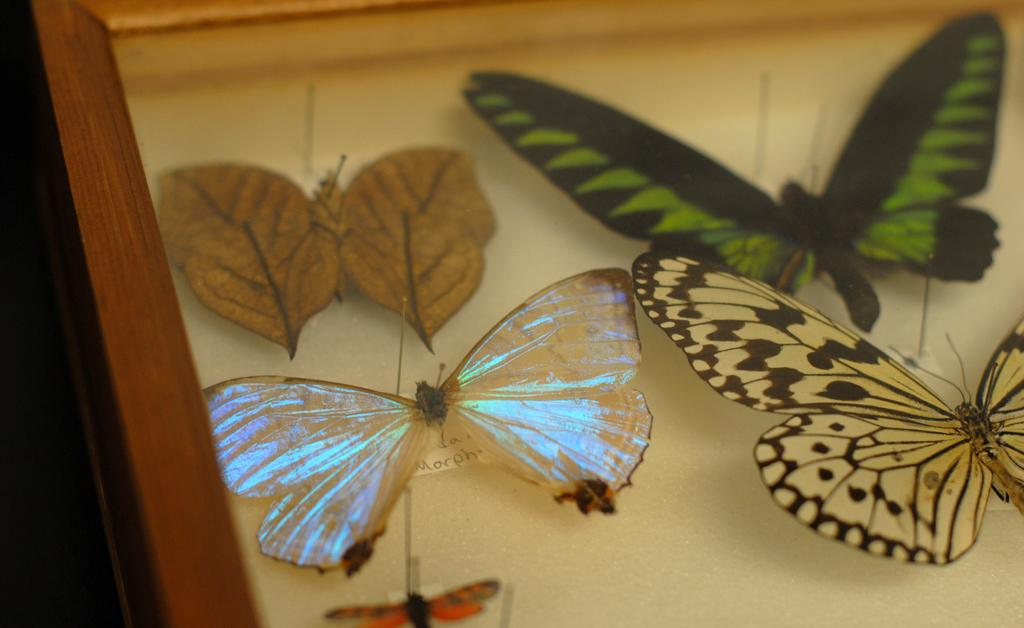What type of creatures can be seen in the image? There are butterflies in the image. Where are the butterflies located? The butterflies are on a case. What can be observed about the appearance of the butterflies? The butterflies are of different colors. What type of frame is used to hold the butterflies in the image? There is no frame mentioned in the image; the butterflies are on a case. Can you hear the butterflies coughing in the image? Butterflies do not have the ability to cough, and there is no sound in the image. 